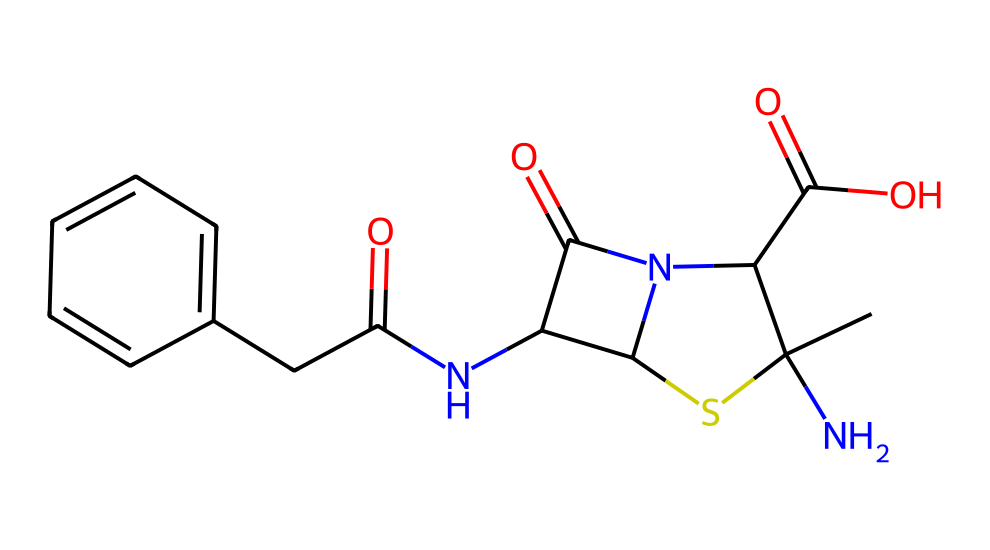What is the molecular formula of amoxicillin? To determine the molecular formula, we need to count the different atoms present in the SMILES representation. By analyzing the structure, we find 16 carbon (C) atoms, 19 hydrogen (H) atoms, 3 nitrogen (N) atoms, 4 oxygen (O) atoms, and 1 sulfur (S) atom. Combining these counts gives us the formula C16H19N3O5S.
Answer: C16H19N3O5S How many rings are present in the structure of amoxicillin? The chemical structure contains a bicyclic system – which can be identified by scanning for the numerical annotations in the SMILES. There are two cycles evident in the molecule, confirming the presence of two rings.
Answer: 2 What is the role of nitrogen atoms in amoxicillin? The nitrogen atoms contribute to the antibiotic's mechanism of action, as they are part of the carboxamide groups and amino groups, which are crucial for binding to bacterial cell targets. So, they primarily serve as functional group sites that help in interacting with enzymes in bacteria.
Answer: functional groups Does amoxicillin contain any sulfur atoms? When examining the SMILES representation, we can see a distinct "S" which indicates the presence of one sulfur atom in the molecule. This contributes to the antibiotic's overall structure and may influence its solubility and activity.
Answer: 1 What is the significance of the carboxylic acid group in amoxicillin? The carboxylic acid group (–COOH) enhances the polarity of the molecule, increasing its solubility in water. This is important for its pharmacokinetic properties, allowing better absorption and distribution in biological tissues.
Answer: increased solubility Identify the type of antibiotic that amoxicillin is classified as. Amoxicillin is a beta-lactam antibiotic. This classification is due to the presence of a beta-lactam ring, which is essential for its antibacterial activity by inhibiting cell wall synthesis in susceptible bacteria.
Answer: beta-lactam 